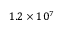<formula> <loc_0><loc_0><loc_500><loc_500>1 . 2 \times 1 0 ^ { 7 }</formula> 